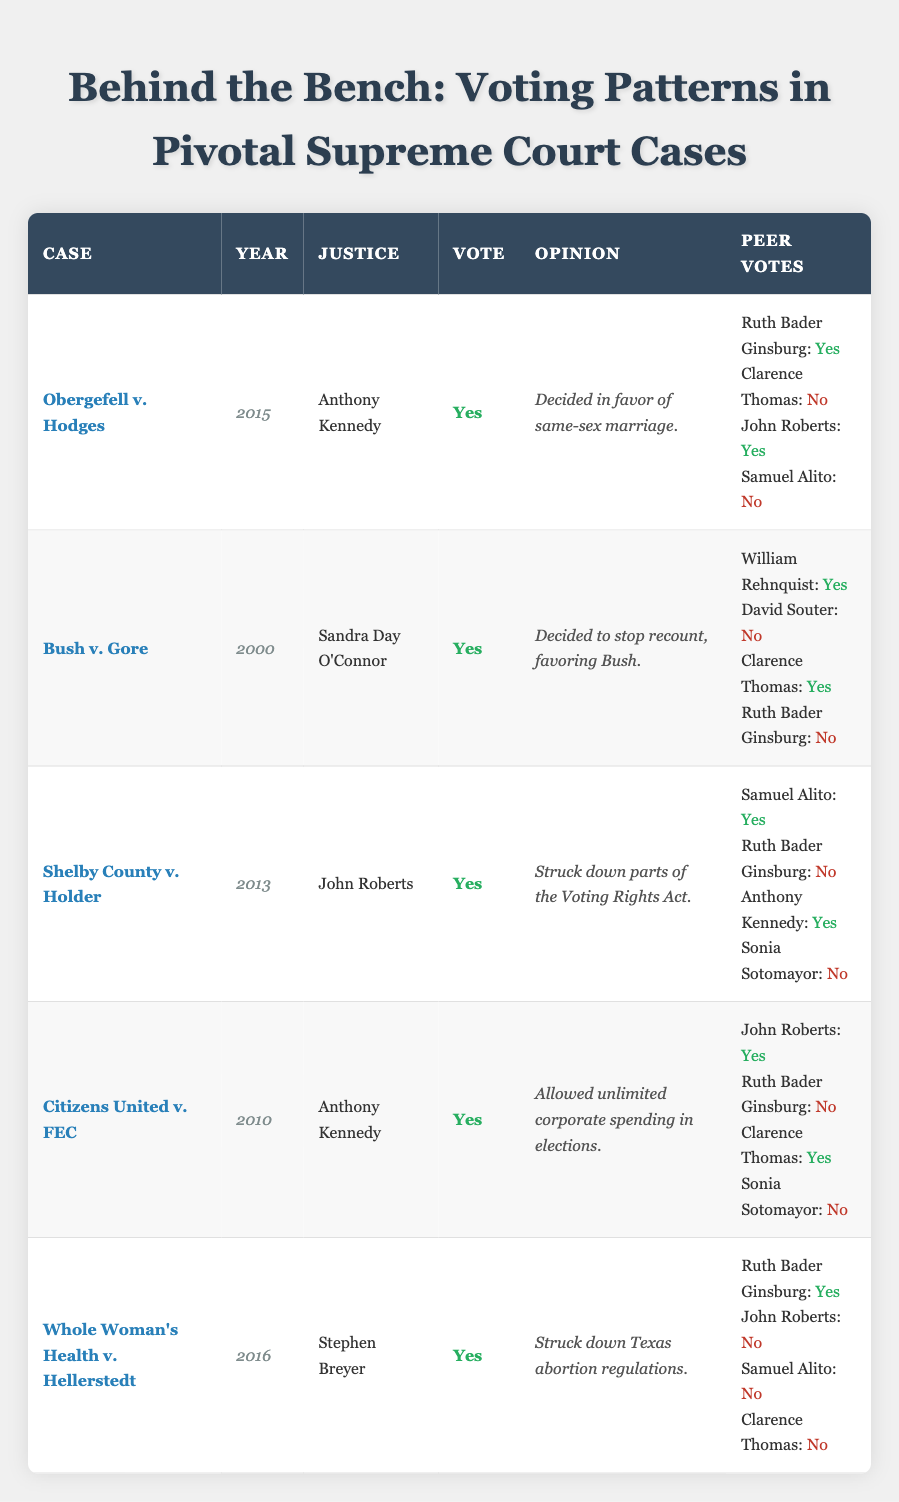What was the vote of Ruth Bader Ginsburg in the case of Obergefell v. Hodges? According to the table, Ruth Bader Ginsburg voted "Yes" in the case of Obergefell v. Hodges.
Answer: Yes Who authored the opinion that favored Bush in Bush v. Gore? The justice who voted "Yes" and authored the opinion in Bush v. Gore is Sandra Day O'Connor.
Answer: Sandra Day O'Connor In how many cases did Anthony Kennedy cast a "Yes" vote? Anthony Kennedy cast a "Yes" vote in three cases: Obergefell v. Hodges, Citizens United v. FEC, and Shelby County v. Holder.
Answer: 3 Did John Roberts vote "No" in any case listed in the table? Checking the table, John Roberts voted "No" in the case of Whole Woman's Health v. Hellerstedt, which means the answer is Yes.
Answer: Yes What is the total number of "Yes" votes cast by justices in the case of Whole Woman's Health v. Hellerstedt? In Whole Woman's Health v. Hellerstedt, Ruth Bader Ginsburg voted "Yes," while the other votes from John Roberts, Samuel Alito, and Clarence Thomas were "No." Thus, the total count of "Yes" votes is 1.
Answer: 1 Which justice voted "No" alongside Ruth Bader Ginsburg in Shelby County v. Holder? The justice who voted "No" alongside Ruth Bader Ginsburg in Shelby County v. Holder is Sonia Sotomayor.
Answer: Sonia Sotomayor What is the majority opinion in Citizens United v. FEC regarding corporate spending? The majority opinion in Citizens United v. FEC, authored by Anthony Kennedy, allowed unlimited corporate spending in elections.
Answer: Allowed unlimited corporate spending Which cases had at least three justices voting "No"? The cases with at least three justices voting "No" are Whole Woman's Health v. Hellerstedt (4 votes) and Shelby County v. Holder (3 votes).
Answer: Whole Woman's Health v. Hellerstedt and Shelby County v. Holder In which year was the case Obergefell v. Hodges decided? The case Obergefell v. Hodges was decided in the year 2015, as indicated in the table.
Answer: 2015 